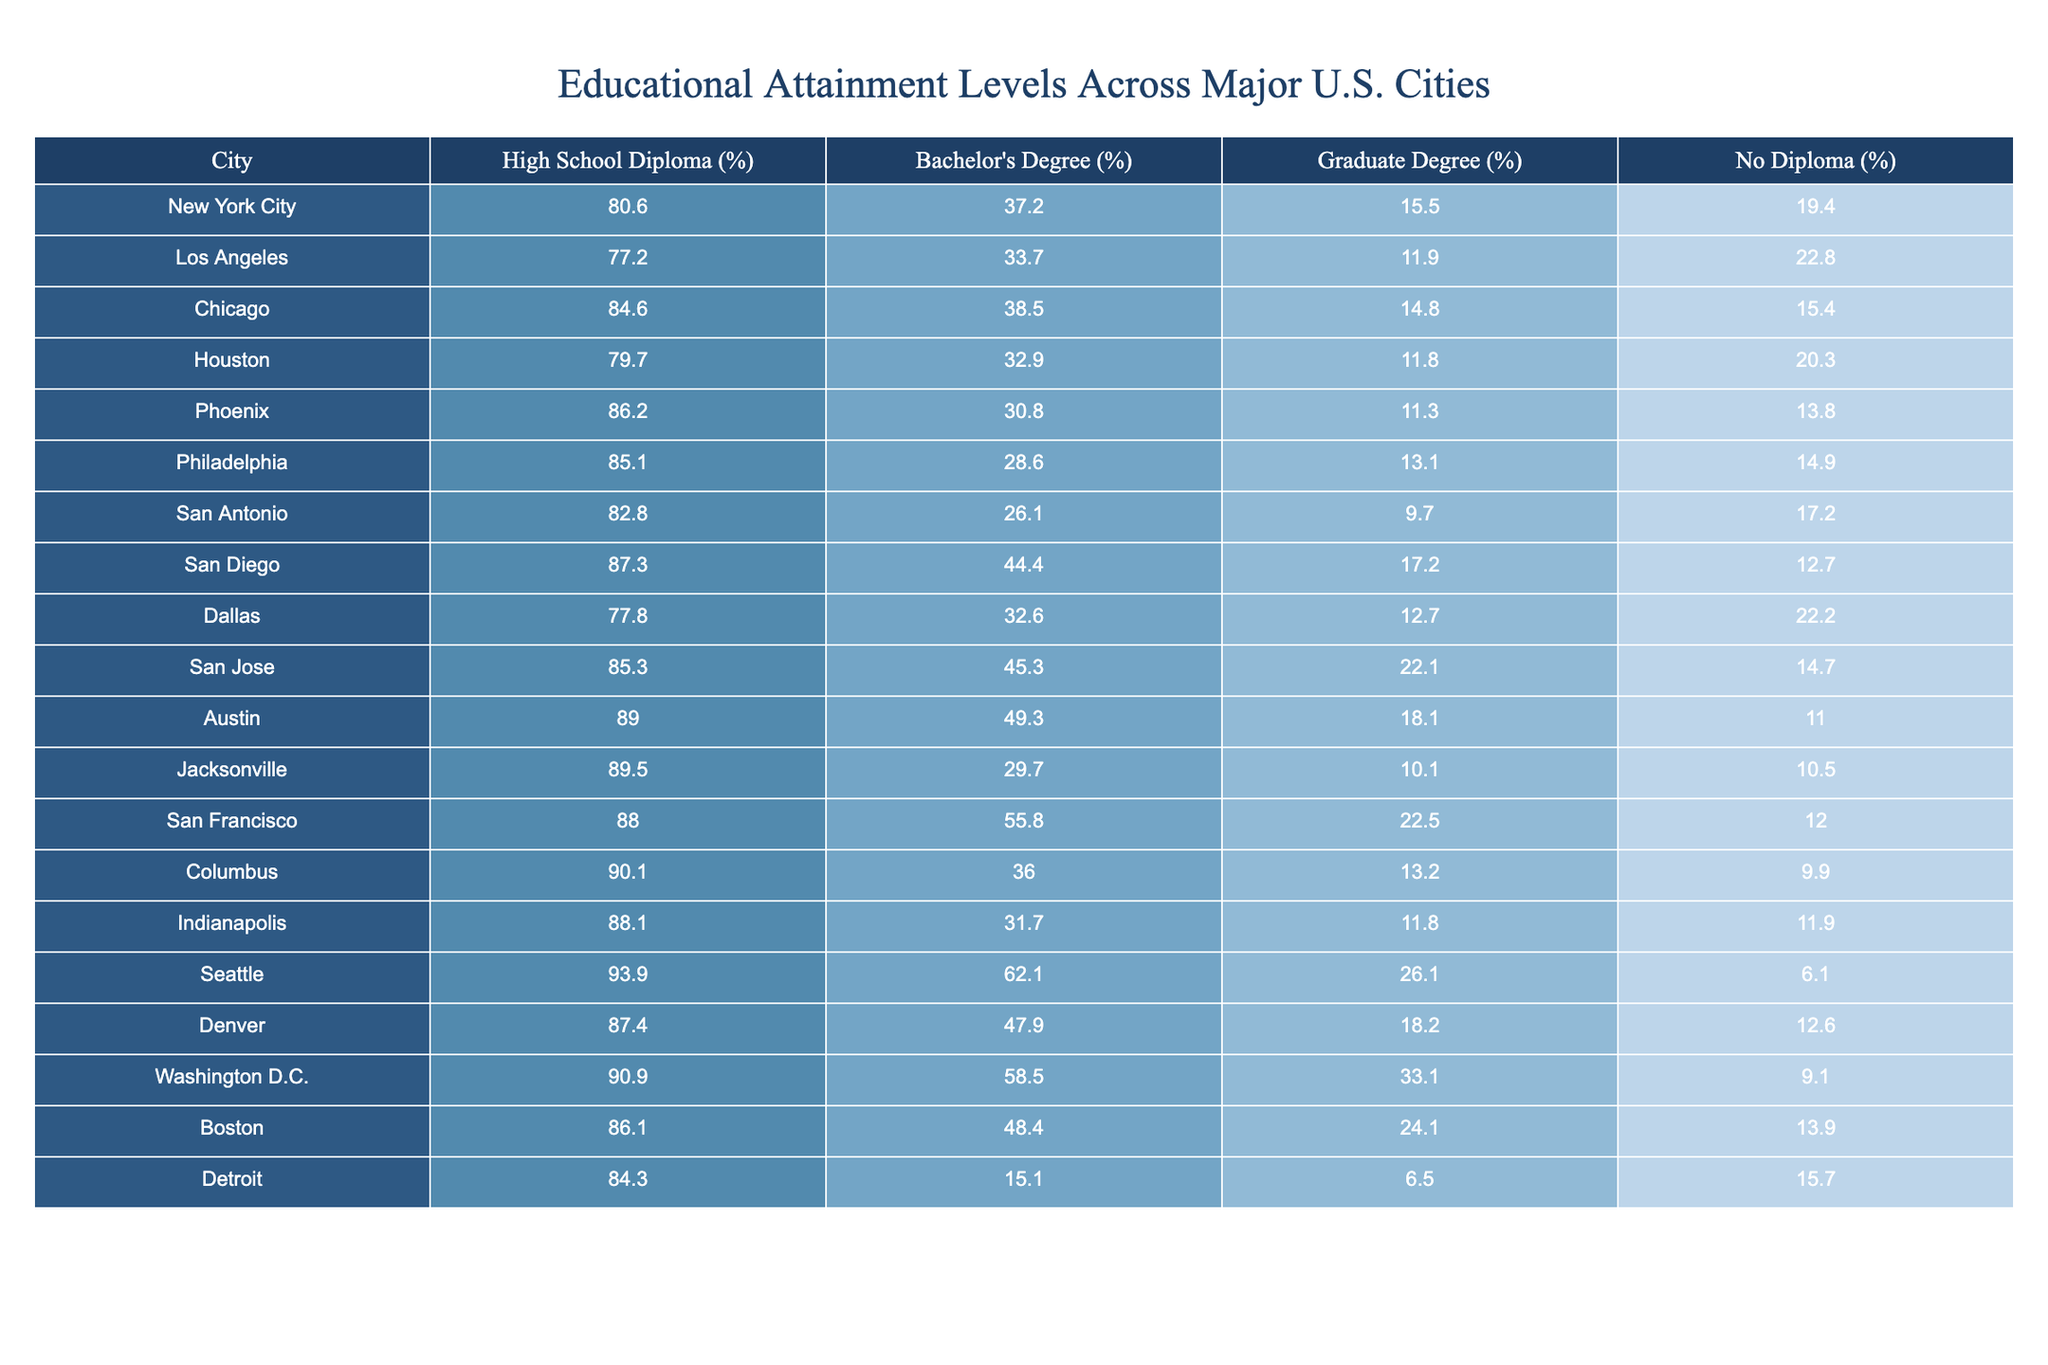What is the percentage of high school diploma holders in Chicago? The table shows that the percentage of high school diploma holders in Chicago is 84.6%.
Answer: 84.6% Which city has the highest percentage of residents with graduate degrees? Looking at the table, Seattle has the highest percentage of graduate degree holders at 26.1%.
Answer: Seattle What is the percentage difference in no diploma rates between New York City and Los Angeles? New York City has 19.4% of residents without a diploma, while Los Angeles has 22.8%. The difference is calculated as 22.8 - 19.4 = 3.4%.
Answer: 3.4% Is the percentage of bachelor's degree holders higher in San Francisco than in San Antonio? The percentage of bachelor's degree holders in San Francisco (55.8%) is indeed higher than in San Antonio (26.1%).
Answer: Yes What is the average percentage of bachelor's degree holders across all listed cities? First, you add up the percentages of bachelor's degree holders: (37.2 + 33.7 + 38.5 + 32.9 + 30.8 + 28.6 + 26.1 + 44.4 + 45.3 + 49.3 + 29.7 + 55.8 + 36.0 + 31.7 + 62.1 + 47.9 + 58.5 + 48.4 + 15.1) =  711.4%. There are 19 cities listed, so the average = 711.4 / 19 = approximately 37.4%.
Answer: 37.4% Which two cities have the lowest percentage of high school diploma holders? A comparison of the high school diploma percentages shows Detroit at 84.3% and Los Angeles at 77.2%, making Los Angeles the lowest.
Answer: Los Angeles and Detroit What percentage of residents in Houston have either a bachelor's or graduate degree? In Houston, 32.9% have a bachelor's degree and 11.8% have a graduate degree. Adding these values gives 32.9 + 11.8 = 44.7%.
Answer: 44.7% Is it true that Austin has a higher percentage of high school diploma holders than Phoenix? Yes, Austin has 89.0% high school diploma holders, while Phoenix has 86.2%.
Answer: Yes Which city has the lowest percentage of graduate degree holders? A quick scan shows that San Antonio has the lowest percentage of graduate degree holders at 9.7%.
Answer: San Antonio What is the combined percentage of residents in Boston without a diploma or with only a high school diploma? Boston has 13.9% without a diploma and 86.1% with at least a high school diploma. Therefore, the combined percentage is 13.9 + (100 - 86.1) = 27.8%.
Answer: 27.8% Which city has the highest percentage of residents who do not have a high school diploma? The data indicates that Los Angeles has the highest percentage of residents without a high school diploma at 22.8%.
Answer: Los Angeles 